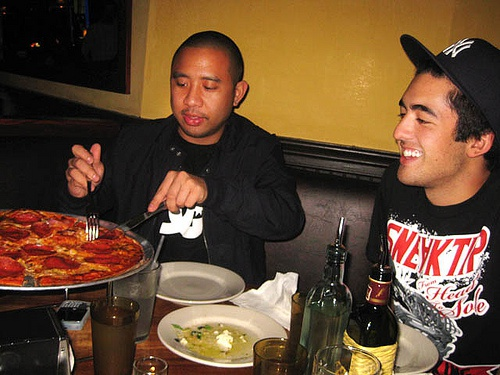Describe the objects in this image and their specific colors. I can see dining table in black, maroon, brown, and tan tones, people in black, white, salmon, and brown tones, people in black, brown, and salmon tones, bench in black and gray tones, and pizza in black, brown, maroon, and red tones in this image. 